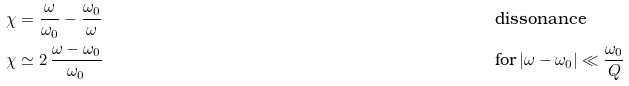Convert formula to latex. <formula><loc_0><loc_0><loc_500><loc_500>\chi & = \frac { \omega } { \omega _ { 0 } } - \frac { \omega _ { 0 } } { \omega } & & \text {dissonance} \\ \chi & \simeq 2 \, \frac { \omega - \omega _ { 0 } } { \omega _ { 0 } } & & \text {for} \left | \omega - \omega _ { 0 } \right | \ll \frac { \omega _ { 0 } } { Q }</formula> 